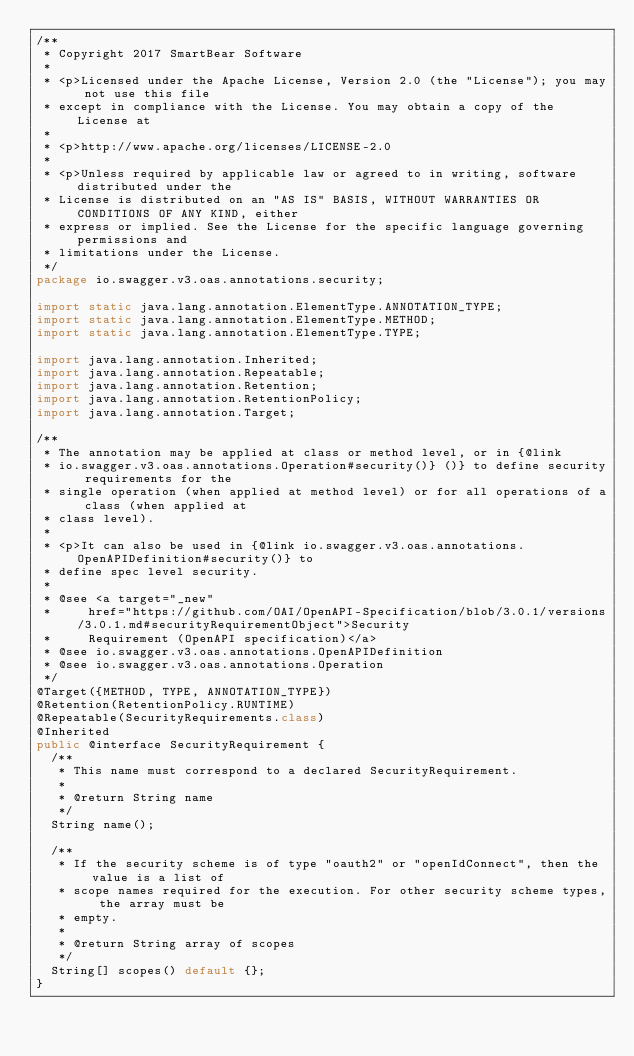<code> <loc_0><loc_0><loc_500><loc_500><_Java_>/**
 * Copyright 2017 SmartBear Software
 *
 * <p>Licensed under the Apache License, Version 2.0 (the "License"); you may not use this file
 * except in compliance with the License. You may obtain a copy of the License at
 *
 * <p>http://www.apache.org/licenses/LICENSE-2.0
 *
 * <p>Unless required by applicable law or agreed to in writing, software distributed under the
 * License is distributed on an "AS IS" BASIS, WITHOUT WARRANTIES OR CONDITIONS OF ANY KIND, either
 * express or implied. See the License for the specific language governing permissions and
 * limitations under the License.
 */
package io.swagger.v3.oas.annotations.security;

import static java.lang.annotation.ElementType.ANNOTATION_TYPE;
import static java.lang.annotation.ElementType.METHOD;
import static java.lang.annotation.ElementType.TYPE;

import java.lang.annotation.Inherited;
import java.lang.annotation.Repeatable;
import java.lang.annotation.Retention;
import java.lang.annotation.RetentionPolicy;
import java.lang.annotation.Target;

/**
 * The annotation may be applied at class or method level, or in {@link
 * io.swagger.v3.oas.annotations.Operation#security()} ()} to define security requirements for the
 * single operation (when applied at method level) or for all operations of a class (when applied at
 * class level).
 *
 * <p>It can also be used in {@link io.swagger.v3.oas.annotations.OpenAPIDefinition#security()} to
 * define spec level security.
 *
 * @see <a target="_new"
 *     href="https://github.com/OAI/OpenAPI-Specification/blob/3.0.1/versions/3.0.1.md#securityRequirementObject">Security
 *     Requirement (OpenAPI specification)</a>
 * @see io.swagger.v3.oas.annotations.OpenAPIDefinition
 * @see io.swagger.v3.oas.annotations.Operation
 */
@Target({METHOD, TYPE, ANNOTATION_TYPE})
@Retention(RetentionPolicy.RUNTIME)
@Repeatable(SecurityRequirements.class)
@Inherited
public @interface SecurityRequirement {
  /**
   * This name must correspond to a declared SecurityRequirement.
   *
   * @return String name
   */
  String name();

  /**
   * If the security scheme is of type "oauth2" or "openIdConnect", then the value is a list of
   * scope names required for the execution. For other security scheme types, the array must be
   * empty.
   *
   * @return String array of scopes
   */
  String[] scopes() default {};
}
</code> 